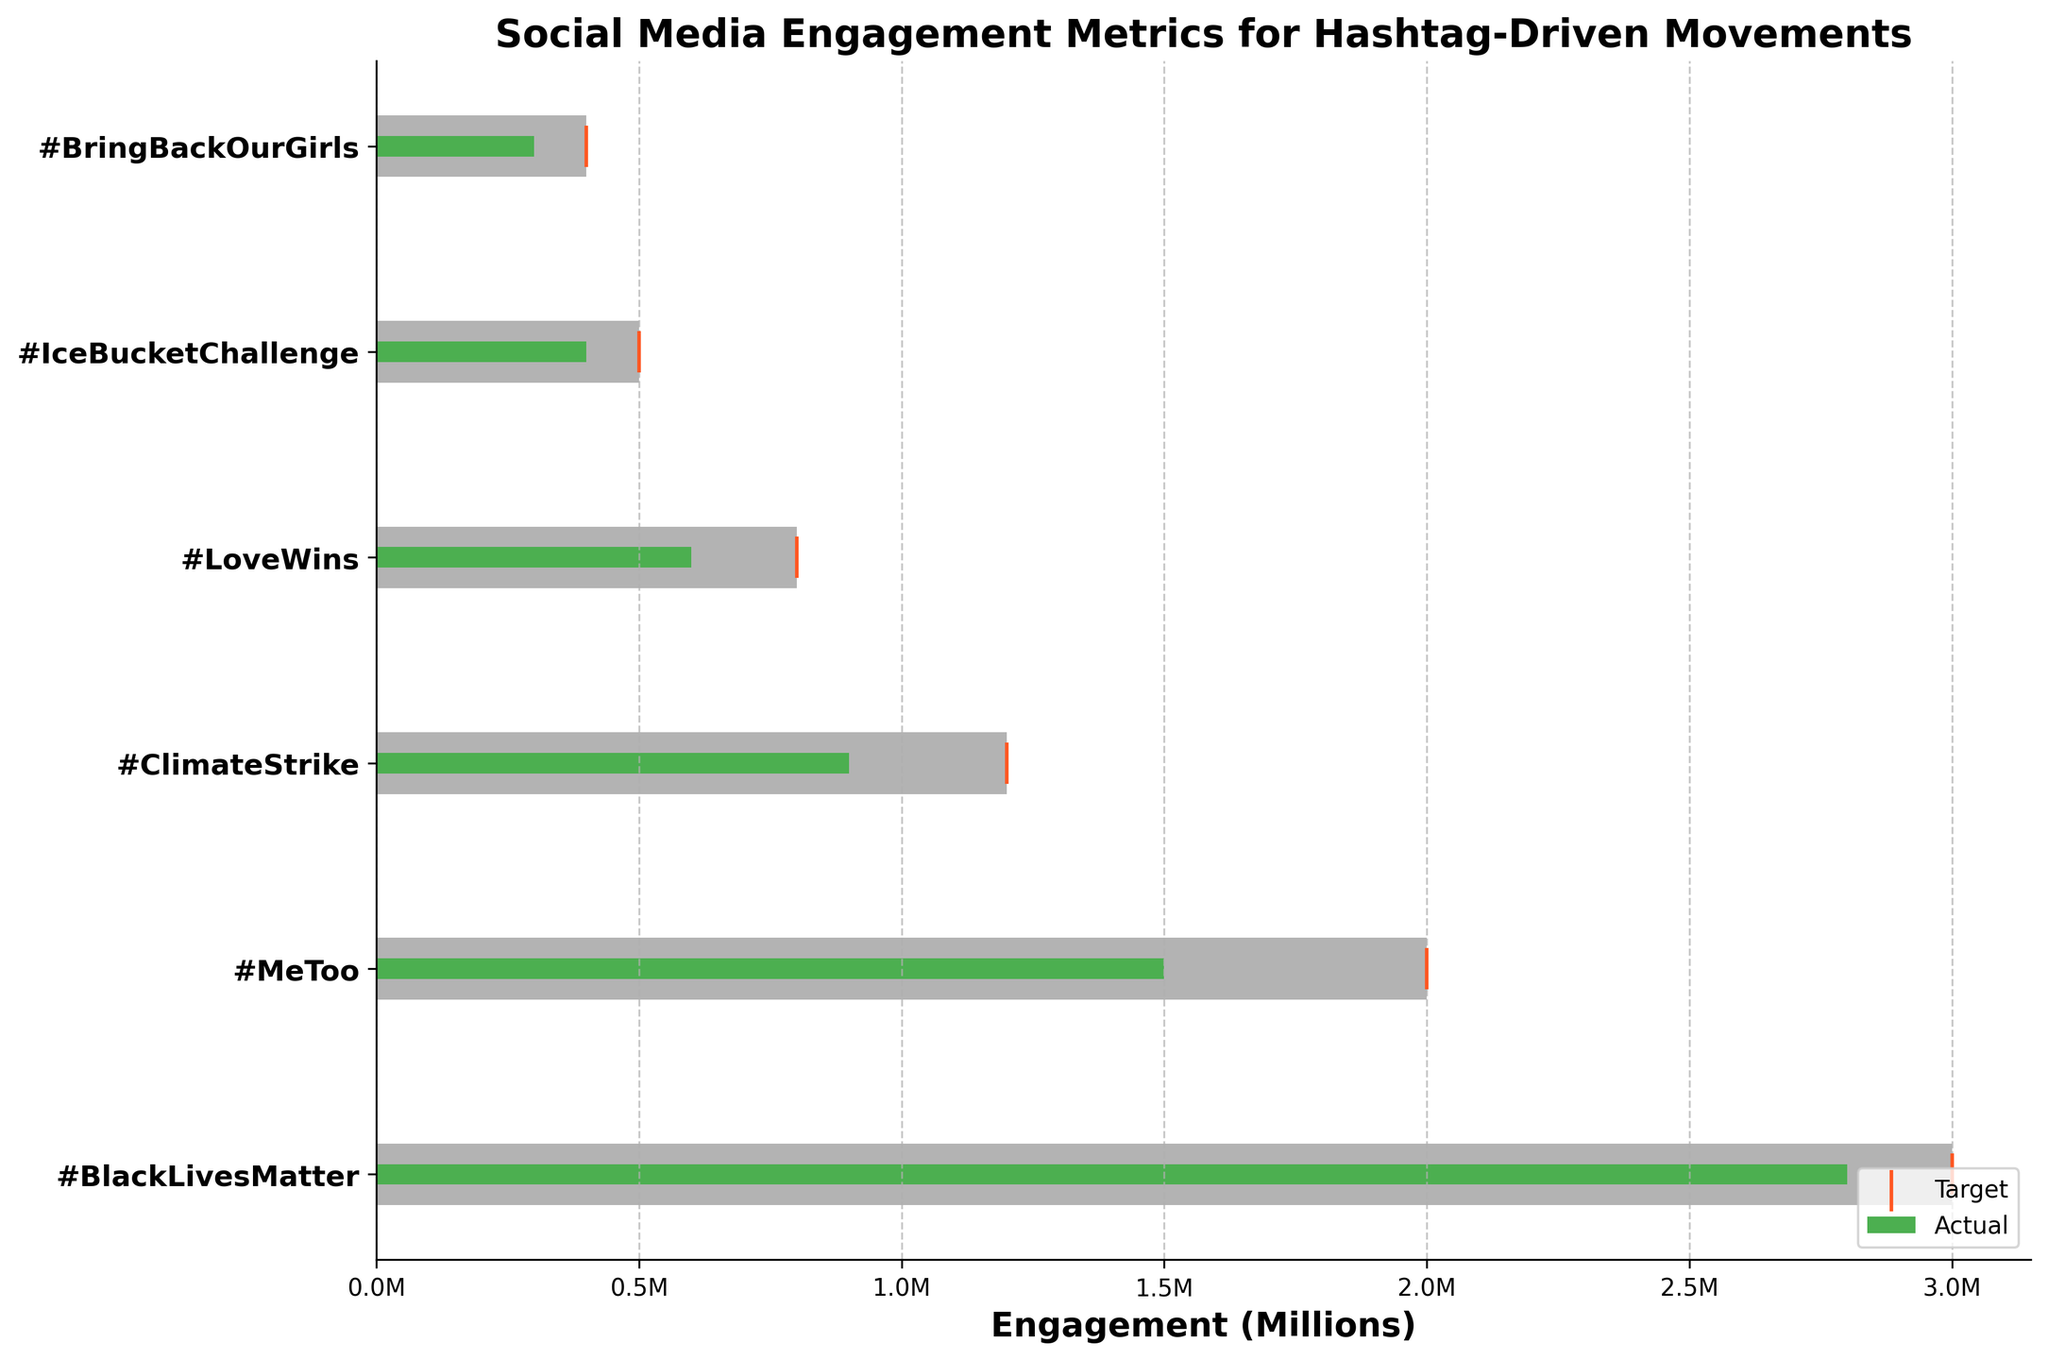What's the title of the bullet chart? The title of the chart is provided at the top of the figure. It is a descriptive label indicating the content and purpose of the chart.
Answer: Social Media Engagement Metrics for Hashtag-Driven Movements What is the engagement target for #MeToo? The scatter marker represented by a vertical line in orange color helps identify the target engagement for each category. For #MeToo, it is labeled on the horizontal axis.
Answer: 2,000,000 Which hashtag has the highest actual engagement? By comparing the green bars which represent the actual engagement values across all hashtags, #BlackLivesMatter clearly has the longest bar, indicating the highest actual engagement.
Answer: #BlackLivesMatter Did the #ClimateStrike movement meet its target engagement? By observing both the green bar (actual engagement) and the orange target marker for #ClimateStrike, the actual engagement (900,000) is less than the target engagement (1,200,000).
Answer: No Rank the hashtags by their engagement target from highest to lowest. By looking at the positions of the orange target markers across the different hashtags, the following order can be determined: #BlackLivesMatter (3M), #MeToo (2M), #ClimateStrike (1.2M), #LoveWins (800K), #IceBucketChallenge (500K), and #BringBackOurGirls (400K).
Answer: #BlackLivesMatter, #MeToo, #ClimateStrike, #LoveWins, #IceBucketChallenge, #BringBackOurGirls Which hashtags fall within the third range of engagement? The third range is represented by the darkest grey bar, which is the highest engagement range for each category. By inspecting the green bars within this range, only #BlackLivesMatter falls within the third range.
Answer: #BlackLivesMatter How much more engagement does #BlackLivesMatter have compared to #MeToo? The actual engagement for #BlackLivesMatter is 2,800,000, while for #MeToo it is 1,500,000; the difference is calculated as 2,800,000 - 1,500,000 = 1,300,000.
Answer: 1,300,000 What is the average actual engagement for the depicted hashtags? To find the average, sum the actual engagement numbers (2,800,000 + 1,500,000 + 900,000 + 600,000 + 400,000 + 300,000 = 6,500,000) and divide by the number of hashtags (6): 6,500,000 / 6 = 1,083,333.
Answer: 1,083,333 